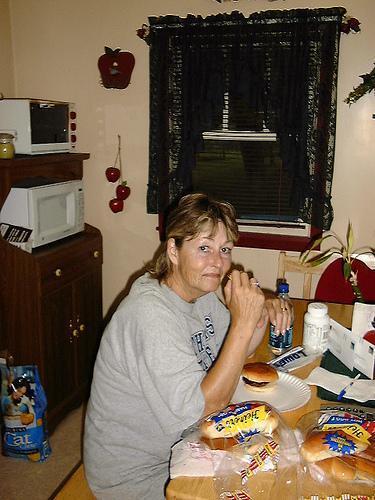How many remotes are on the table?
Give a very brief answer. 0. How many microwaves are in the picture?
Give a very brief answer. 2. How many dining tables can be seen?
Give a very brief answer. 1. 